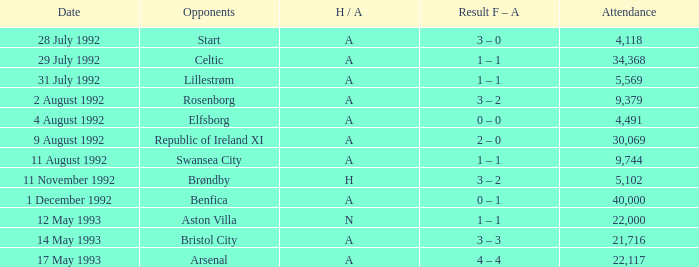Which Result F-A has Opponents of rosenborg? 3 – 2. 